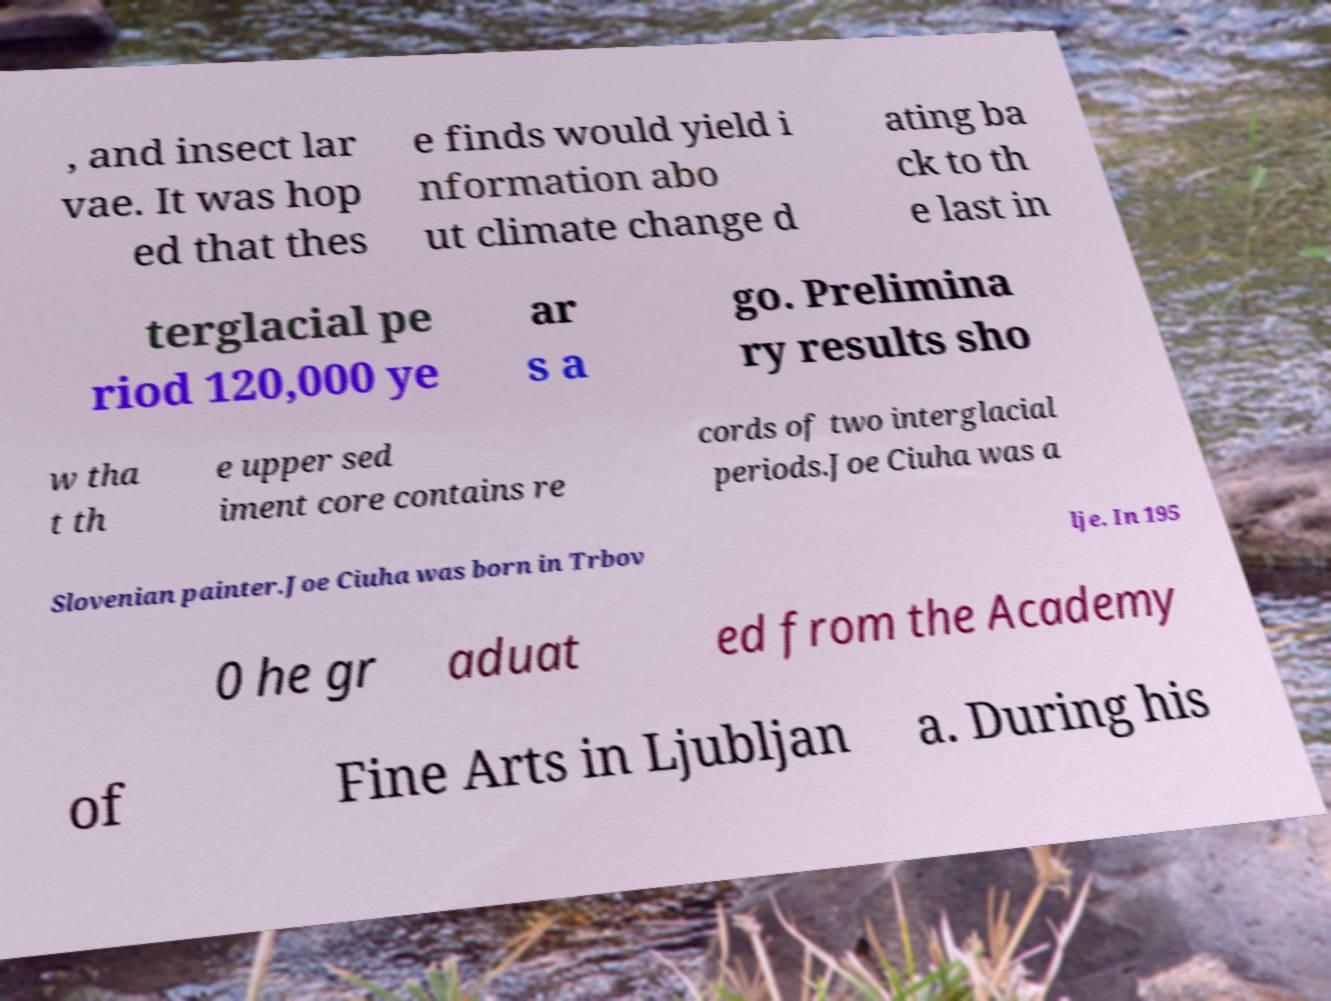Please read and relay the text visible in this image. What does it say? , and insect lar vae. It was hop ed that thes e finds would yield i nformation abo ut climate change d ating ba ck to th e last in terglacial pe riod 120,000 ye ar s a go. Prelimina ry results sho w tha t th e upper sed iment core contains re cords of two interglacial periods.Joe Ciuha was a Slovenian painter.Joe Ciuha was born in Trbov lje. In 195 0 he gr aduat ed from the Academy of Fine Arts in Ljubljan a. During his 